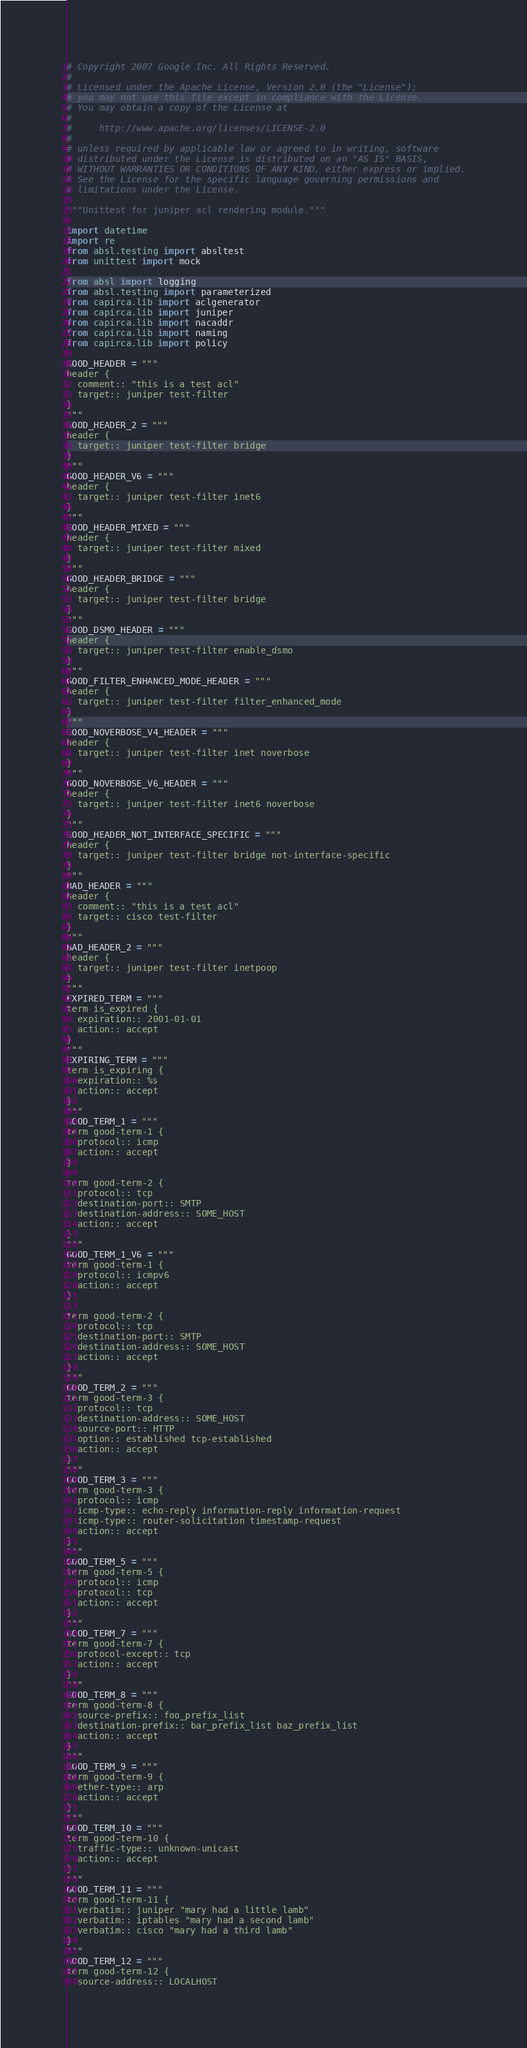Convert code to text. <code><loc_0><loc_0><loc_500><loc_500><_Python_># Copyright 2007 Google Inc. All Rights Reserved.
#
# Licensed under the Apache License, Version 2.0 (the "License");
# you may not use this file except in compliance with the License.
# You may obtain a copy of the License at
#
#     http://www.apache.org/licenses/LICENSE-2.0
#
# unless required by applicable law or agreed to in writing, software
# distributed under the License is distributed on an "AS IS" BASIS,
# WITHOUT WARRANTIES OR CONDITIONS OF ANY KIND, either express or implied.
# See the License for the specific language governing permissions and
# limitations under the License.

"""Unittest for juniper acl rendering module."""

import datetime
import re
from absl.testing import absltest
from unittest import mock

from absl import logging
from absl.testing import parameterized
from capirca.lib import aclgenerator
from capirca.lib import juniper
from capirca.lib import nacaddr
from capirca.lib import naming
from capirca.lib import policy

GOOD_HEADER = """
header {
  comment:: "this is a test acl"
  target:: juniper test-filter
}
"""
GOOD_HEADER_2 = """
header {
  target:: juniper test-filter bridge
}
"""
GOOD_HEADER_V6 = """
header {
  target:: juniper test-filter inet6
}
"""
GOOD_HEADER_MIXED = """
header {
  target:: juniper test-filter mixed
}
"""
GOOD_HEADER_BRIDGE = """
header {
  target:: juniper test-filter bridge
}
"""
GOOD_DSMO_HEADER = """
header {
  target:: juniper test-filter enable_dsmo
}
"""
GOOD_FILTER_ENHANCED_MODE_HEADER = """
header {
  target:: juniper test-filter filter_enhanced_mode
}
"""
GOOD_NOVERBOSE_V4_HEADER = """
header {
  target:: juniper test-filter inet noverbose
}
"""
GOOD_NOVERBOSE_V6_HEADER = """
header {
  target:: juniper test-filter inet6 noverbose
}
"""
GOOD_HEADER_NOT_INTERFACE_SPECIFIC = """
header {
  target:: juniper test-filter bridge not-interface-specific
}
"""
BAD_HEADER = """
header {
  comment:: "this is a test acl"
  target:: cisco test-filter
}
"""
BAD_HEADER_2 = """
header {
  target:: juniper test-filter inetpoop
}
"""
EXPIRED_TERM = """
term is_expired {
  expiration:: 2001-01-01
  action:: accept
}
"""
EXPIRING_TERM = """
term is_expiring {
  expiration:: %s
  action:: accept
}
"""
GOOD_TERM_1 = """
term good-term-1 {
  protocol:: icmp
  action:: accept
}

term good-term-2 {
  protocol:: tcp
  destination-port:: SMTP
  destination-address:: SOME_HOST
  action:: accept
}
"""
GOOD_TERM_1_V6 = """
term good-term-1 {
  protocol:: icmpv6
  action:: accept
}

term good-term-2 {
  protocol:: tcp
  destination-port:: SMTP
  destination-address:: SOME_HOST
  action:: accept
}
"""
GOOD_TERM_2 = """
term good-term-3 {
  protocol:: tcp
  destination-address:: SOME_HOST
  source-port:: HTTP
  option:: established tcp-established
  action:: accept
}
"""
GOOD_TERM_3 = """
term good-term-3 {
  protocol:: icmp
  icmp-type:: echo-reply information-reply information-request
  icmp-type:: router-solicitation timestamp-request
  action:: accept
}
"""
GOOD_TERM_5 = """
term good-term-5 {
  protocol:: icmp
  protocol:: tcp
  action:: accept
}
"""
GOOD_TERM_7 = """
term good-term-7 {
  protocol-except:: tcp
  action:: accept
}
"""
GOOD_TERM_8 = """
term good-term-8 {
  source-prefix:: foo_prefix_list
  destination-prefix:: bar_prefix_list baz_prefix_list
  action:: accept
}
"""
GOOD_TERM_9 = """
term good-term-9 {
  ether-type:: arp
  action:: accept
}
"""
GOOD_TERM_10 = """
term good-term-10 {
  traffic-type:: unknown-unicast
  action:: accept
}
"""
GOOD_TERM_11 = """
term good-term-11 {
  verbatim:: juniper "mary had a little lamb"
  verbatim:: iptables "mary had a second lamb"
  verbatim:: cisco "mary had a third lamb"
}
"""
GOOD_TERM_12 = """
term good-term-12 {
  source-address:: LOCALHOST</code> 